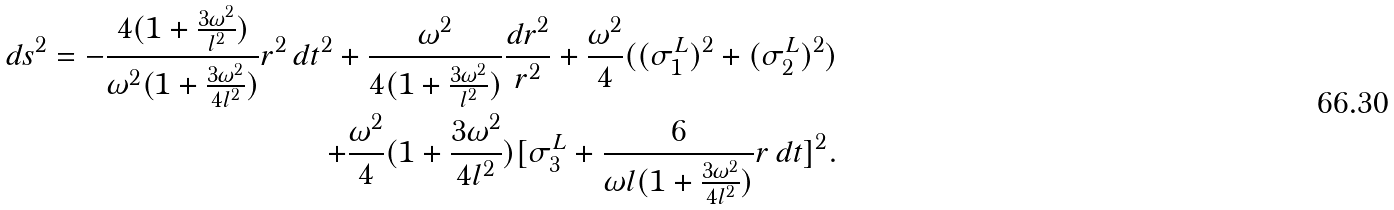<formula> <loc_0><loc_0><loc_500><loc_500>d s ^ { 2 } = - \frac { 4 ( 1 + \frac { 3 \omega ^ { 2 } } { l ^ { 2 } } ) } { \omega ^ { 2 } ( 1 + \frac { 3 \omega ^ { 2 } } { 4 l ^ { 2 } } ) } r ^ { 2 } \, d t ^ { 2 } + \frac { \omega ^ { 2 } } { 4 ( 1 + \frac { 3 \omega ^ { 2 } } { l ^ { 2 } } ) } \frac { d r ^ { 2 } } { r ^ { 2 } } + \frac { \omega ^ { 2 } } { 4 } ( ( \sigma _ { 1 } ^ { L } ) ^ { 2 } + ( \sigma _ { 2 } ^ { L } ) ^ { 2 } ) \\ + \frac { \omega ^ { 2 } } { 4 } ( 1 + \frac { 3 \omega ^ { 2 } } { 4 l ^ { 2 } } ) [ \sigma _ { 3 } ^ { L } + \frac { 6 } { \omega l ( 1 + \frac { 3 \omega ^ { 2 } } { 4 l ^ { 2 } } ) } r \, d t ] ^ { 2 } .</formula> 